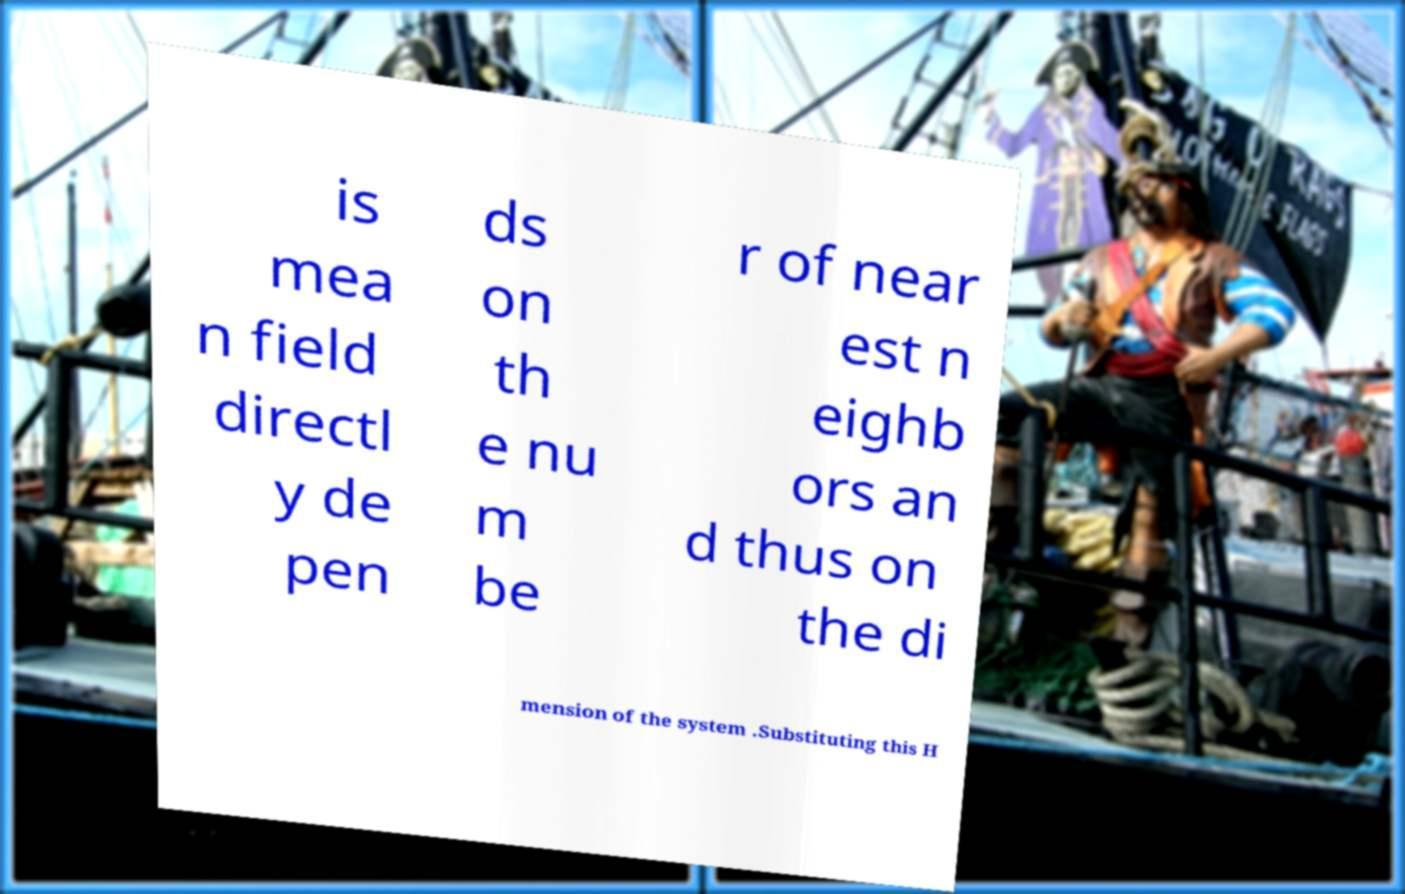Can you read and provide the text displayed in the image?This photo seems to have some interesting text. Can you extract and type it out for me? is mea n field directl y de pen ds on th e nu m be r of near est n eighb ors an d thus on the di mension of the system .Substituting this H 